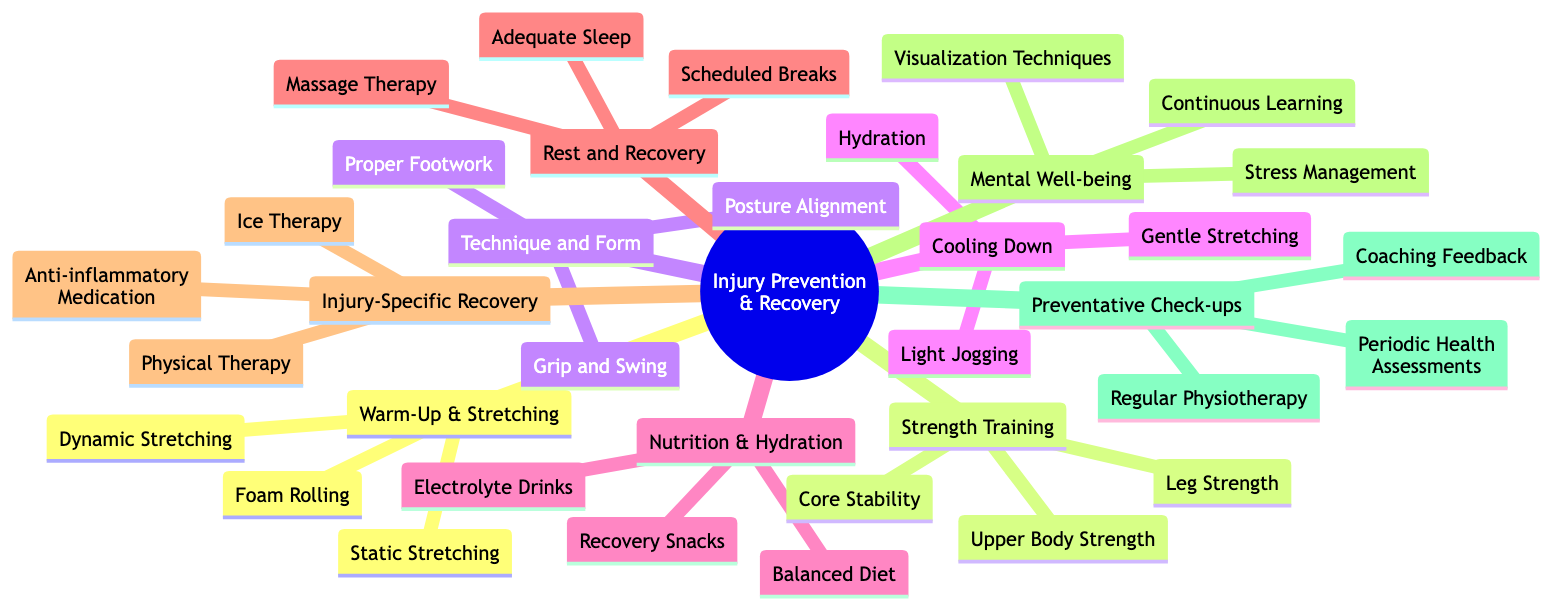What are the four main categories of injury prevention techniques? The diagram has the root node labeled "Injury Prevention & Recovery," which branches out into four primary categories: Warm-Up & Stretching, Strength Training, Technique and Form, and Cooling Down.
Answer: Warm-Up & Stretching, Strength Training, Technique and Form, Cooling Down How many techniques are listed under Nutrition & Hydration? In the diagram, the Nutrition & Hydration category has three sub-nodes: Balanced Diet, Electrolyte Drinks, and Recovery Snacks. Therefore, the number of techniques listed is three.
Answer: 3 Which technique is listed under Rest and Recovery that focuses on sleep? The Rest and Recovery category includes Adequate Sleep as one of its sub-nodes, which directly addresses the focus on sleep.
Answer: Adequate Sleep Which category includes "Stress Management" as a technique? The Mental Well-being category contains "Stress Management." This can be confirmed as we navigate through the diagram to identify techniques specifically associated with Mental Well-being.
Answer: Mental Well-being Name one technique that falls under Injury-Specific Recovery. In the Injury-Specific Recovery section, the techniques listed include Ice Therapy, Physical Therapy, and Anti-inflammatory Medication. Any of these would answer the question.
Answer: Ice Therapy What is the relationship between Nutrition & Hydration and Cooling Down categories? Both categories are part of the overarching root node "Injury Prevention & Recovery," indicating they are parallel branches under the same main topic but do not directly connect to each other.
Answer: Parallel branches How many techniques focus on physical aspects like strength and form? In total, Strength Training has three techniques (Core Stability, Leg Strength, Upper Body Strength) and Technique and Form has three techniques (Proper Footwork, Grip and Swing, Posture Alignment). Therefore, the total is six techniques focusing on physical aspects.
Answer: 6 What sub-technique is under Strength Training that emphasizes stability? The Core Stability technique is specifically listed under the Strength Training category, highlighting its focus on stability.
Answer: Core Stability 